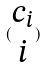Convert formula to latex. <formula><loc_0><loc_0><loc_500><loc_500>( \begin{matrix} c _ { i } \\ i \end{matrix} )</formula> 